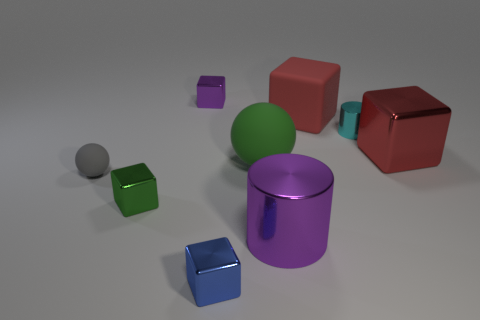Subtract 2 blocks. How many blocks are left? 3 Subtract all brown blocks. Subtract all blue cylinders. How many blocks are left? 5 Subtract all cylinders. How many objects are left? 7 Add 3 red matte objects. How many red matte objects are left? 4 Add 9 big purple things. How many big purple things exist? 10 Subtract 1 green spheres. How many objects are left? 8 Subtract all tiny cyan cylinders. Subtract all big purple shiny cylinders. How many objects are left? 7 